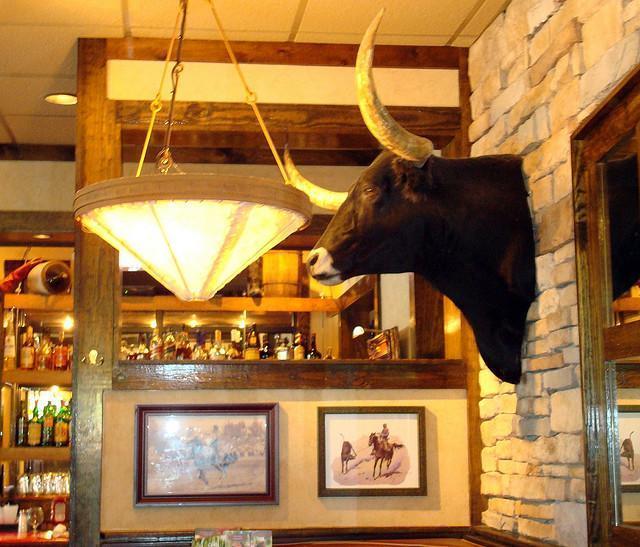How many of the women are wearing short sleeves?
Give a very brief answer. 0. 